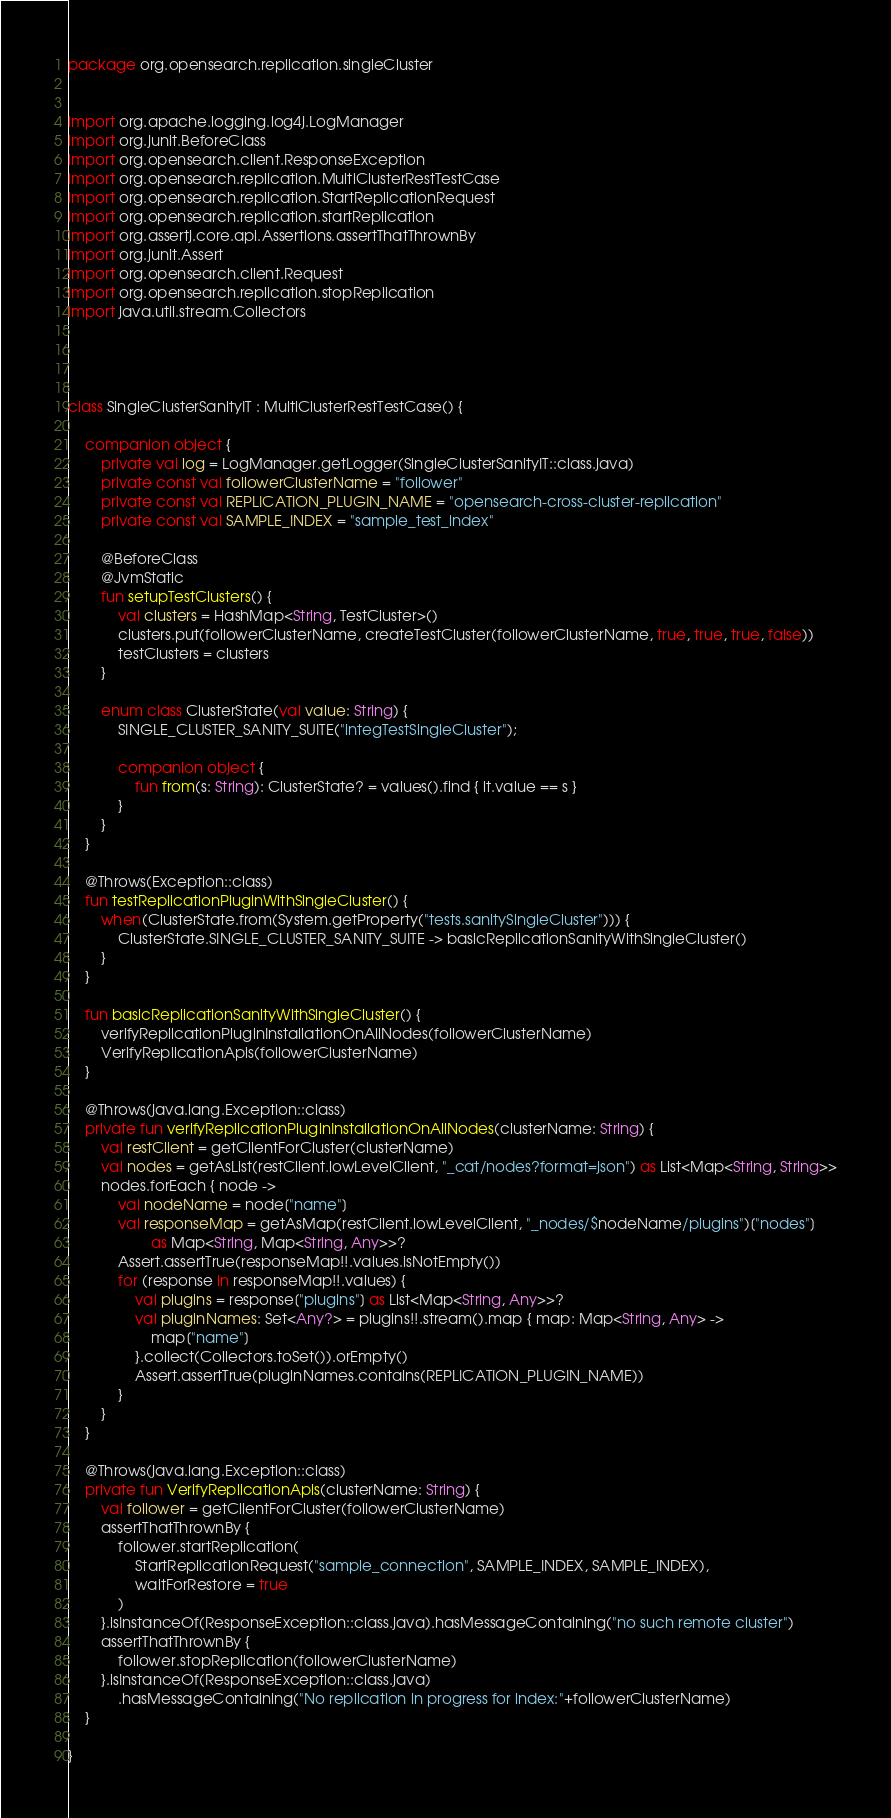<code> <loc_0><loc_0><loc_500><loc_500><_Kotlin_>package org.opensearch.replication.singleCluster


import org.apache.logging.log4j.LogManager
import org.junit.BeforeClass
import org.opensearch.client.ResponseException
import org.opensearch.replication.MultiClusterRestTestCase
import org.opensearch.replication.StartReplicationRequest
import org.opensearch.replication.startReplication
import org.assertj.core.api.Assertions.assertThatThrownBy
import org.junit.Assert
import org.opensearch.client.Request
import org.opensearch.replication.stopReplication
import java.util.stream.Collectors




class SingleClusterSanityIT : MultiClusterRestTestCase() {

    companion object {
        private val log = LogManager.getLogger(SingleClusterSanityIT::class.java)
        private const val followerClusterName = "follower"
        private const val REPLICATION_PLUGIN_NAME = "opensearch-cross-cluster-replication"
        private const val SAMPLE_INDEX = "sample_test_index"

        @BeforeClass
        @JvmStatic
        fun setupTestClusters() {
            val clusters = HashMap<String, TestCluster>()
            clusters.put(followerClusterName, createTestCluster(followerClusterName, true, true, true, false))
            testClusters = clusters
        }

        enum class ClusterState(val value: String) {
            SINGLE_CLUSTER_SANITY_SUITE("integTestSingleCluster");

            companion object {
                fun from(s: String): ClusterState? = values().find { it.value == s }
            }
        }
    }

    @Throws(Exception::class)
    fun testReplicationPluginWithSingleCluster() {
        when(ClusterState.from(System.getProperty("tests.sanitySingleCluster"))) {
            ClusterState.SINGLE_CLUSTER_SANITY_SUITE -> basicReplicationSanityWithSingleCluster()
        }
    }

    fun basicReplicationSanityWithSingleCluster() {
        verifyReplicationPluginInstallationOnAllNodes(followerClusterName)
        VerifyReplicationApis(followerClusterName)
    }

    @Throws(java.lang.Exception::class)
    private fun verifyReplicationPluginInstallationOnAllNodes(clusterName: String) {
        val restClient = getClientForCluster(clusterName)
        val nodes = getAsList(restClient.lowLevelClient, "_cat/nodes?format=json") as List<Map<String, String>>
        nodes.forEach { node ->
            val nodeName = node["name"]
            val responseMap = getAsMap(restClient.lowLevelClient, "_nodes/$nodeName/plugins")["nodes"]
                    as Map<String, Map<String, Any>>?
            Assert.assertTrue(responseMap!!.values.isNotEmpty())
            for (response in responseMap!!.values) {
                val plugins = response["plugins"] as List<Map<String, Any>>?
                val pluginNames: Set<Any?> = plugins!!.stream().map { map: Map<String, Any> ->
                    map["name"]
                }.collect(Collectors.toSet()).orEmpty()
                Assert.assertTrue(pluginNames.contains(REPLICATION_PLUGIN_NAME))
            }
        }
    }

    @Throws(java.lang.Exception::class)
    private fun VerifyReplicationApis(clusterName: String) {
        val follower = getClientForCluster(followerClusterName)
        assertThatThrownBy {
            follower.startReplication(
                StartReplicationRequest("sample_connection", SAMPLE_INDEX, SAMPLE_INDEX),
                waitForRestore = true
            )
        }.isInstanceOf(ResponseException::class.java).hasMessageContaining("no such remote cluster")
        assertThatThrownBy {
            follower.stopReplication(followerClusterName)
        }.isInstanceOf(ResponseException::class.java)
            .hasMessageContaining("No replication in progress for index:"+followerClusterName)
    }

}

</code> 